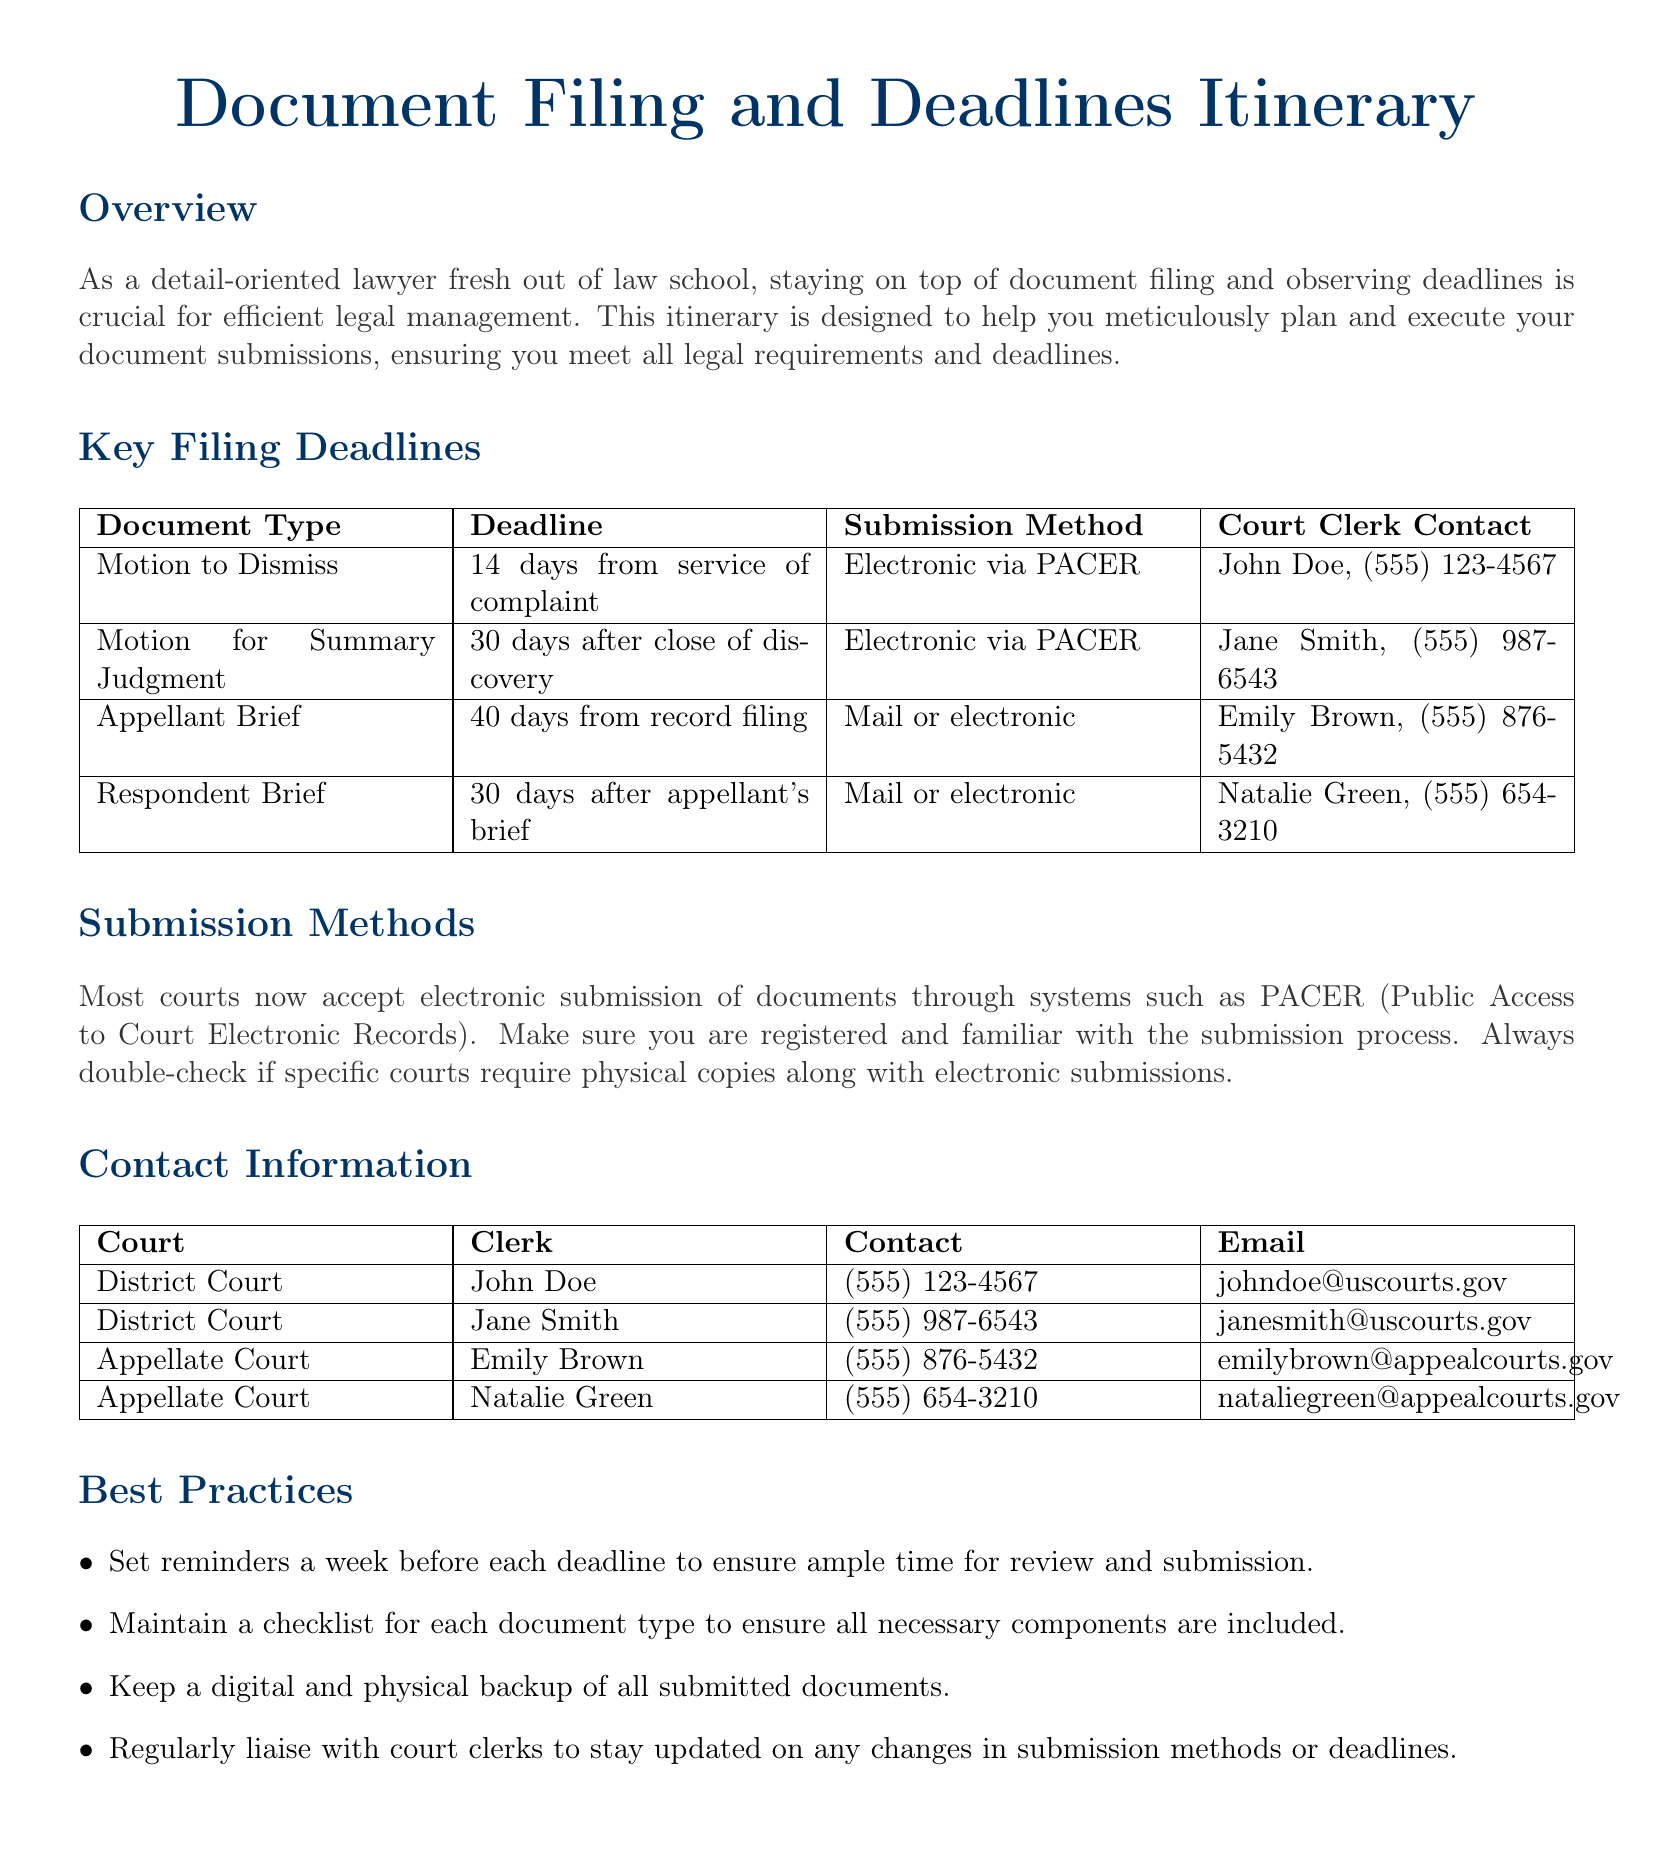What is the deadline for a Motion to Dismiss? The deadline is specified in the document as 14 days from service of complaint.
Answer: 14 days Who is the Clerk for the Appellate Court? The document lists two clerks for the Appellate Court, Emily Brown and Natalie Green.
Answer: Emily Brown, Natalie Green What is the submission method for the Respondent Brief? The document states that the Respondent Brief can be submitted by mail or electronic.
Answer: Mail or electronic How many days do you have to file an Appellant Brief? The document specifies that an Appellant Brief is due 40 days from record filing.
Answer: 40 days What should you do a week before each deadline? According to the best practices section, you should set reminders a week before each deadline.
Answer: Set reminders Which court clerk's contact number is (555) 987-6543? The document indicates that Jane Smith is the court clerk with this contact number.
Answer: Jane Smith What is one of the best practices mentioned for document submission? The best practices section lists several practices, including maintaining a checklist for each document type.
Answer: Maintain a checklist What is required for filing a Motion for Summary Judgment? The document states that a Motion for Summary Judgment must be filed within 30 days after the close of discovery.
Answer: 30 days after close of discovery 